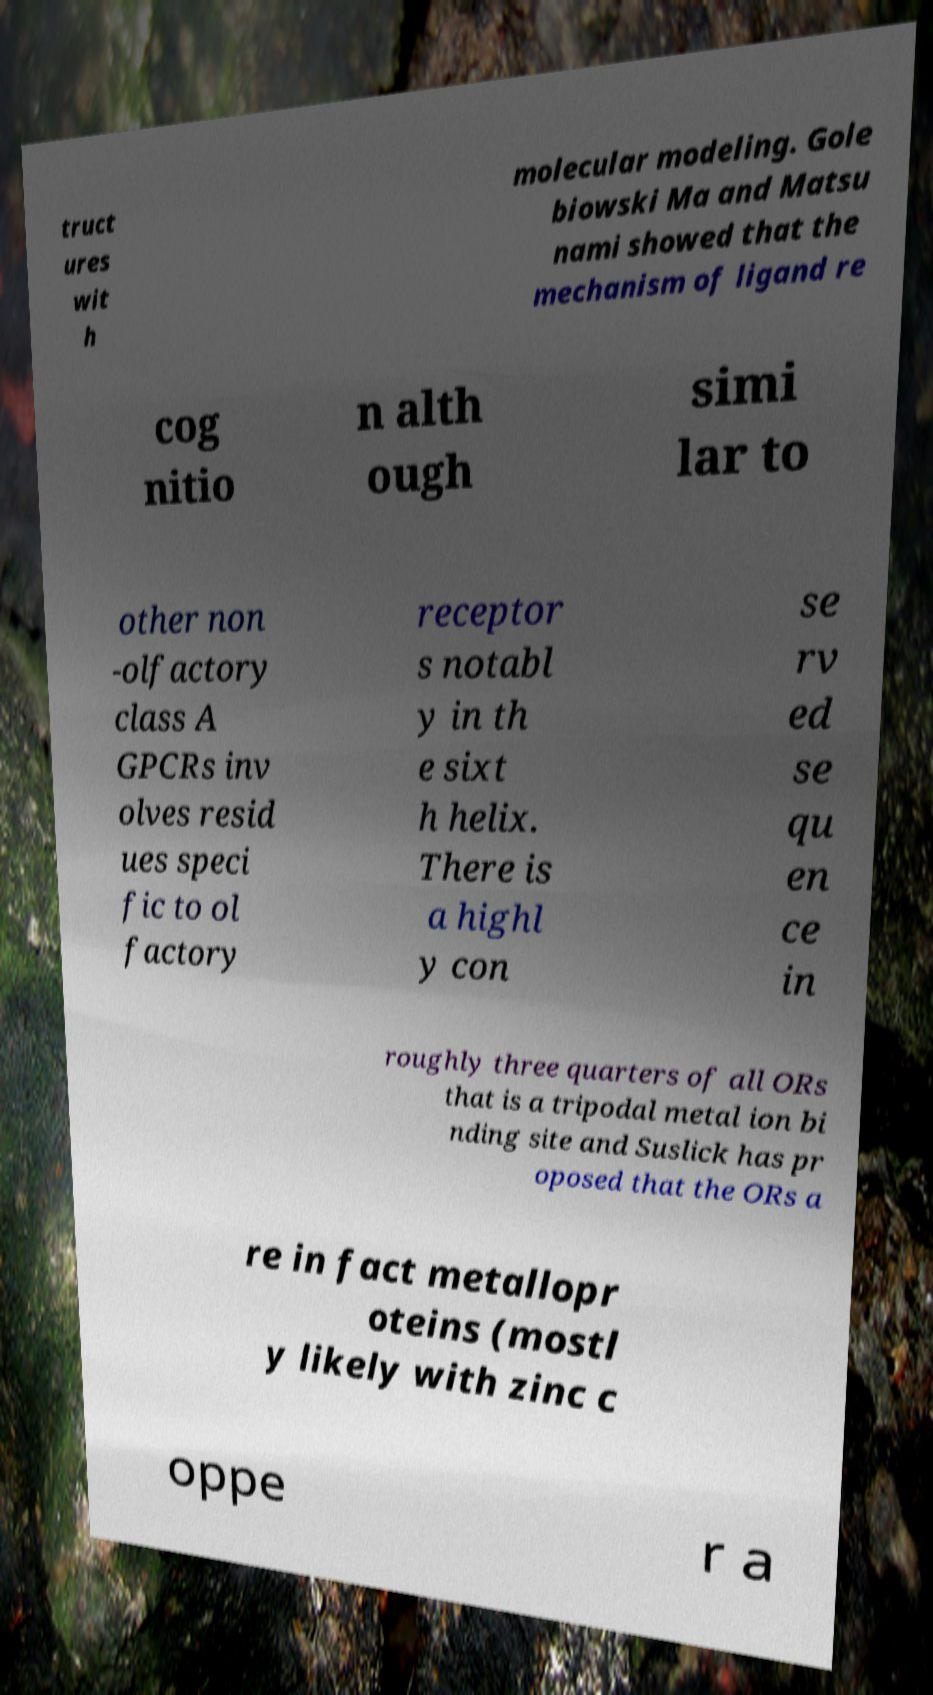Could you assist in decoding the text presented in this image and type it out clearly? truct ures wit h molecular modeling. Gole biowski Ma and Matsu nami showed that the mechanism of ligand re cog nitio n alth ough simi lar to other non -olfactory class A GPCRs inv olves resid ues speci fic to ol factory receptor s notabl y in th e sixt h helix. There is a highl y con se rv ed se qu en ce in roughly three quarters of all ORs that is a tripodal metal ion bi nding site and Suslick has pr oposed that the ORs a re in fact metallopr oteins (mostl y likely with zinc c oppe r a 